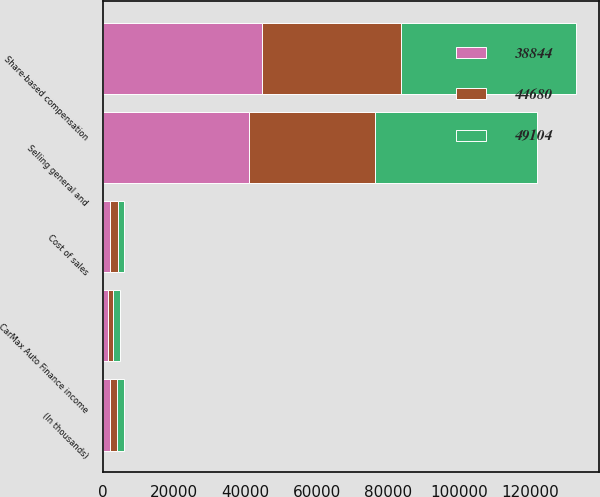<chart> <loc_0><loc_0><loc_500><loc_500><stacked_bar_chart><ecel><fcel>(In thousands)<fcel>Cost of sales<fcel>CarMax Auto Finance income<fcel>Selling general and<fcel>Share-based compensation<nl><fcel>49104<fcel>2012<fcel>1845<fcel>1867<fcel>45392<fcel>49104<nl><fcel>38844<fcel>2011<fcel>2081<fcel>1603<fcel>40996<fcel>44680<nl><fcel>44680<fcel>2010<fcel>2103<fcel>1334<fcel>35407<fcel>38844<nl></chart> 